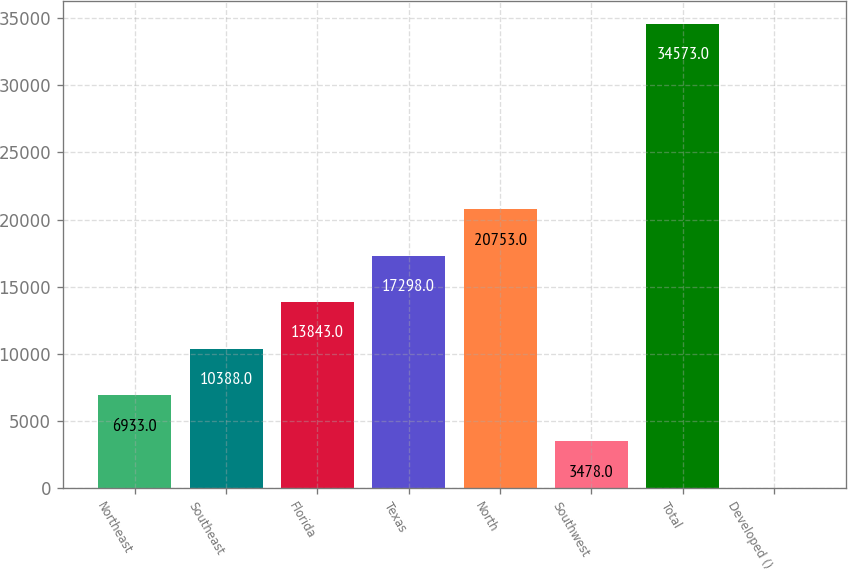Convert chart. <chart><loc_0><loc_0><loc_500><loc_500><bar_chart><fcel>Northeast<fcel>Southeast<fcel>Florida<fcel>Texas<fcel>North<fcel>Southwest<fcel>Total<fcel>Developed ()<nl><fcel>6933<fcel>10388<fcel>13843<fcel>17298<fcel>20753<fcel>3478<fcel>34573<fcel>23<nl></chart> 